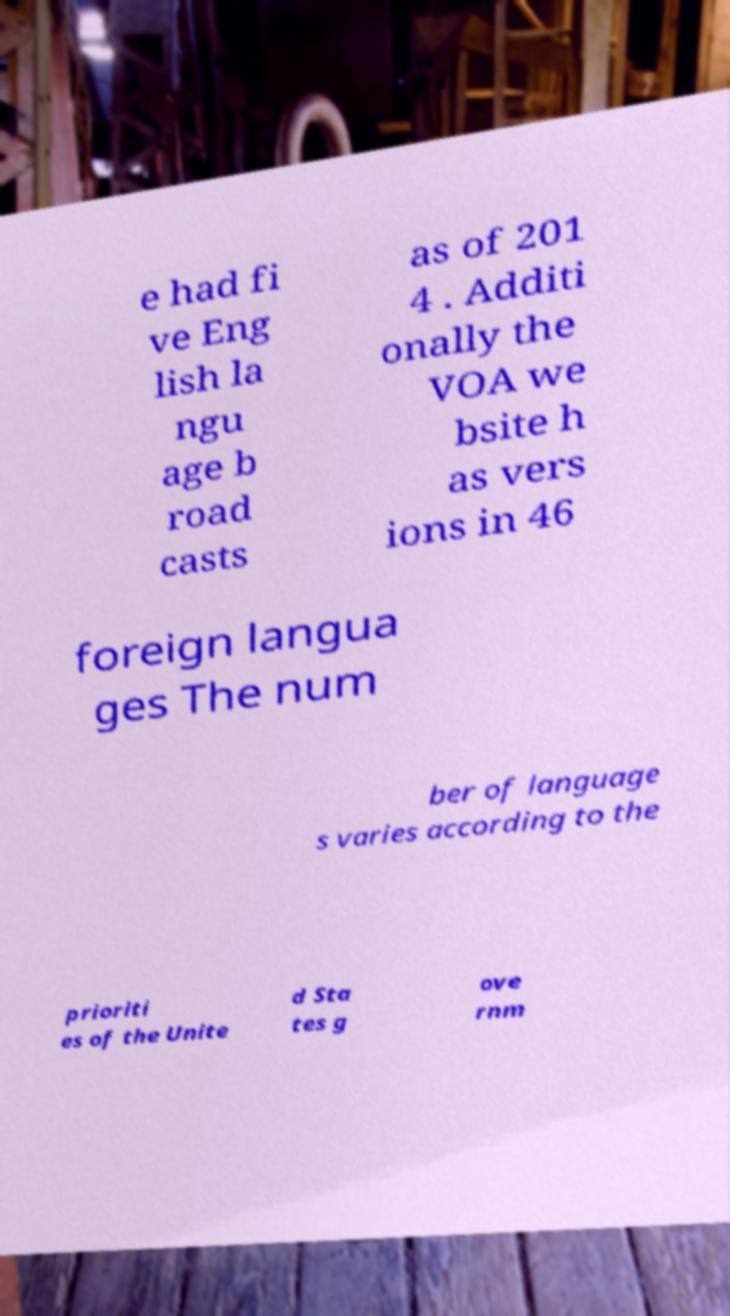Please identify and transcribe the text found in this image. e had fi ve Eng lish la ngu age b road casts as of 201 4 . Additi onally the VOA we bsite h as vers ions in 46 foreign langua ges The num ber of language s varies according to the prioriti es of the Unite d Sta tes g ove rnm 